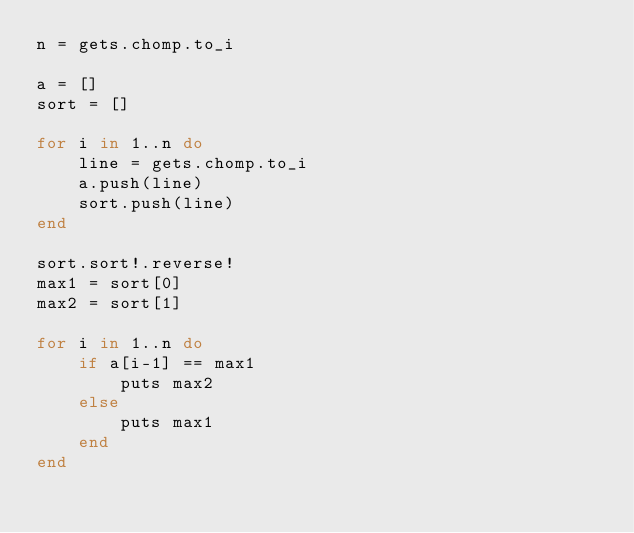<code> <loc_0><loc_0><loc_500><loc_500><_Ruby_>n = gets.chomp.to_i

a = []
sort = []

for i in 1..n do
    line = gets.chomp.to_i
    a.push(line)
    sort.push(line)
end

sort.sort!.reverse!
max1 = sort[0]
max2 = sort[1]

for i in 1..n do 
    if a[i-1] == max1
        puts max2
    else
        puts max1
    end
end</code> 